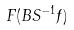Convert formula to latex. <formula><loc_0><loc_0><loc_500><loc_500>F ( B S ^ { - 1 } f )</formula> 